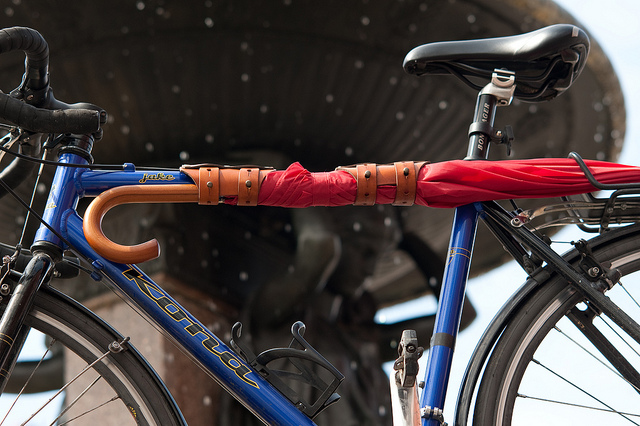<image>How is the umbrella attached to the bike? I am not sure how the umbrella is attached to the bike. It could be with straps or belts. How is the umbrella attached to the bike? I am not sure how the umbrella is attached to the bike. It can be seen with straps or belts. 